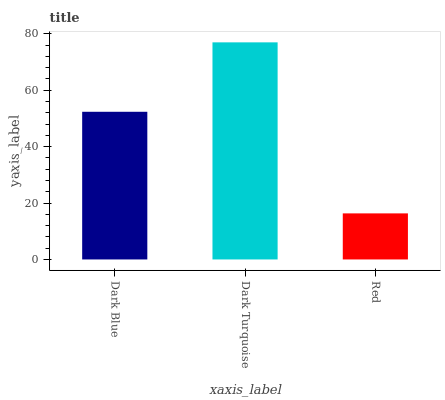Is Red the minimum?
Answer yes or no. Yes. Is Dark Turquoise the maximum?
Answer yes or no. Yes. Is Dark Turquoise the minimum?
Answer yes or no. No. Is Red the maximum?
Answer yes or no. No. Is Dark Turquoise greater than Red?
Answer yes or no. Yes. Is Red less than Dark Turquoise?
Answer yes or no. Yes. Is Red greater than Dark Turquoise?
Answer yes or no. No. Is Dark Turquoise less than Red?
Answer yes or no. No. Is Dark Blue the high median?
Answer yes or no. Yes. Is Dark Blue the low median?
Answer yes or no. Yes. Is Red the high median?
Answer yes or no. No. Is Red the low median?
Answer yes or no. No. 